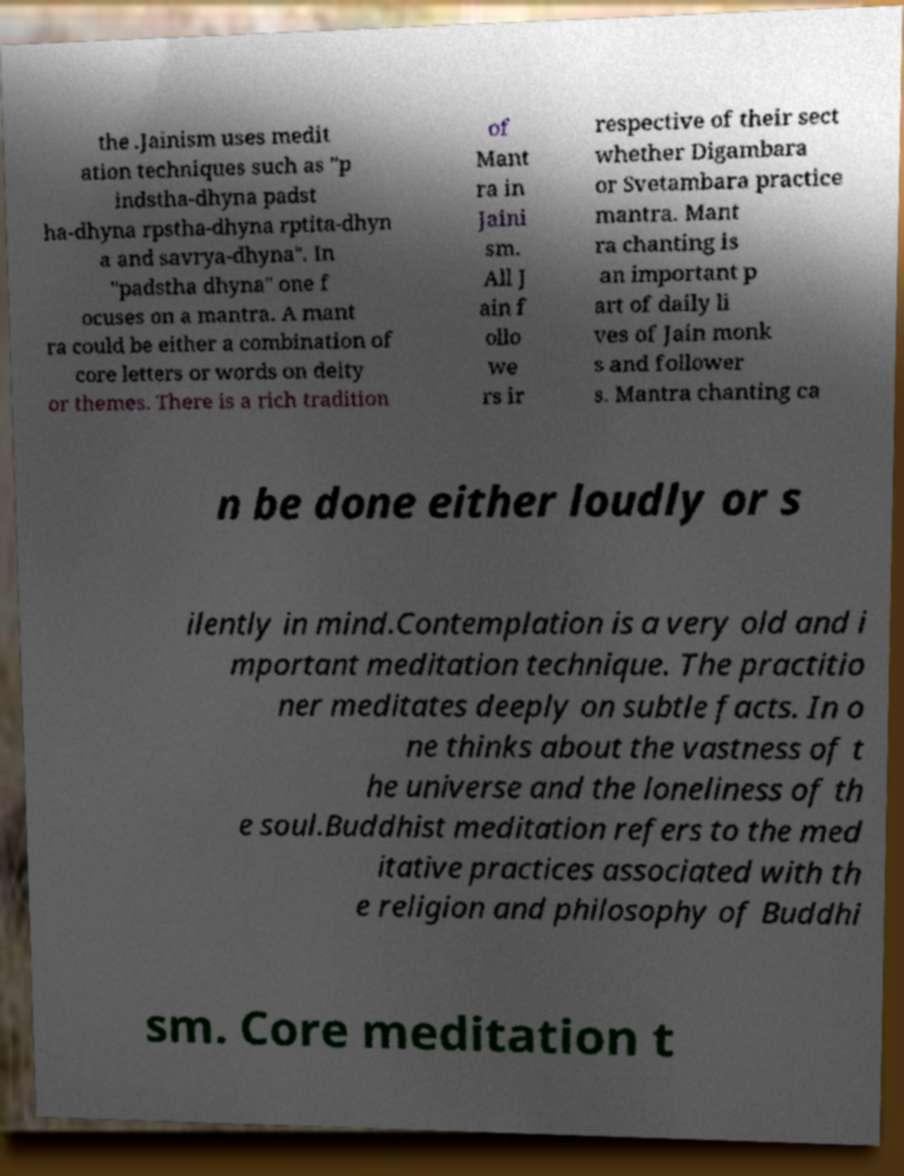Could you assist in decoding the text presented in this image and type it out clearly? the .Jainism uses medit ation techniques such as "p indstha-dhyna padst ha-dhyna rpstha-dhyna rptita-dhyn a and savrya-dhyna". In "padstha dhyna" one f ocuses on a mantra. A mant ra could be either a combination of core letters or words on deity or themes. There is a rich tradition of Mant ra in Jaini sm. All J ain f ollo we rs ir respective of their sect whether Digambara or Svetambara practice mantra. Mant ra chanting is an important p art of daily li ves of Jain monk s and follower s. Mantra chanting ca n be done either loudly or s ilently in mind.Contemplation is a very old and i mportant meditation technique. The practitio ner meditates deeply on subtle facts. In o ne thinks about the vastness of t he universe and the loneliness of th e soul.Buddhist meditation refers to the med itative practices associated with th e religion and philosophy of Buddhi sm. Core meditation t 